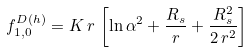Convert formula to latex. <formula><loc_0><loc_0><loc_500><loc_500>f _ { 1 , 0 } ^ { D ( h ) } = K \, r \, \left [ \ln \alpha ^ { 2 } + \frac { R _ { s } } { r } + \frac { R _ { s } ^ { 2 } } { 2 \, r ^ { 2 } } \right ]</formula> 